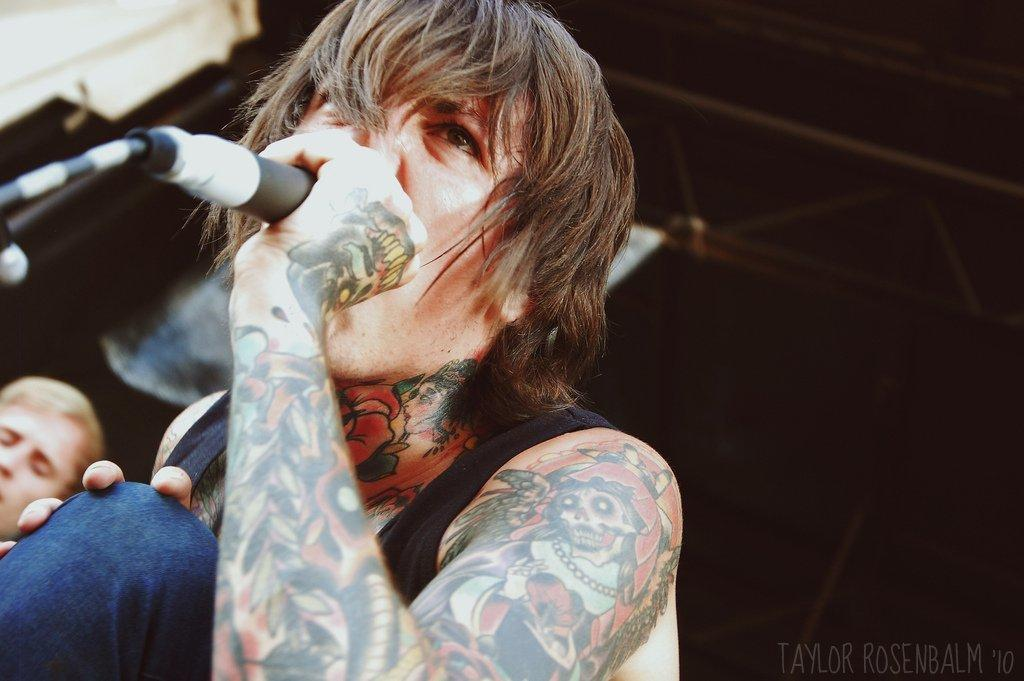What is the man in the image doing? The man is singing. What is the man holding in the image? The man is holding a microphone. Can you describe the image details about the man's appearance be described? Yes, the man has tattoos. Is there another person visible in the image? Yes, there is another man's face visible in the image. What type of mask is the man wearing while singing in the image? There is no mask present in the image; the man is not wearing a mask while singing. Can you tell me which animals are in the zoo that the man is visiting in the image? There is no mention of a zoo or any animals in the image; it features a man singing with a microphone. 